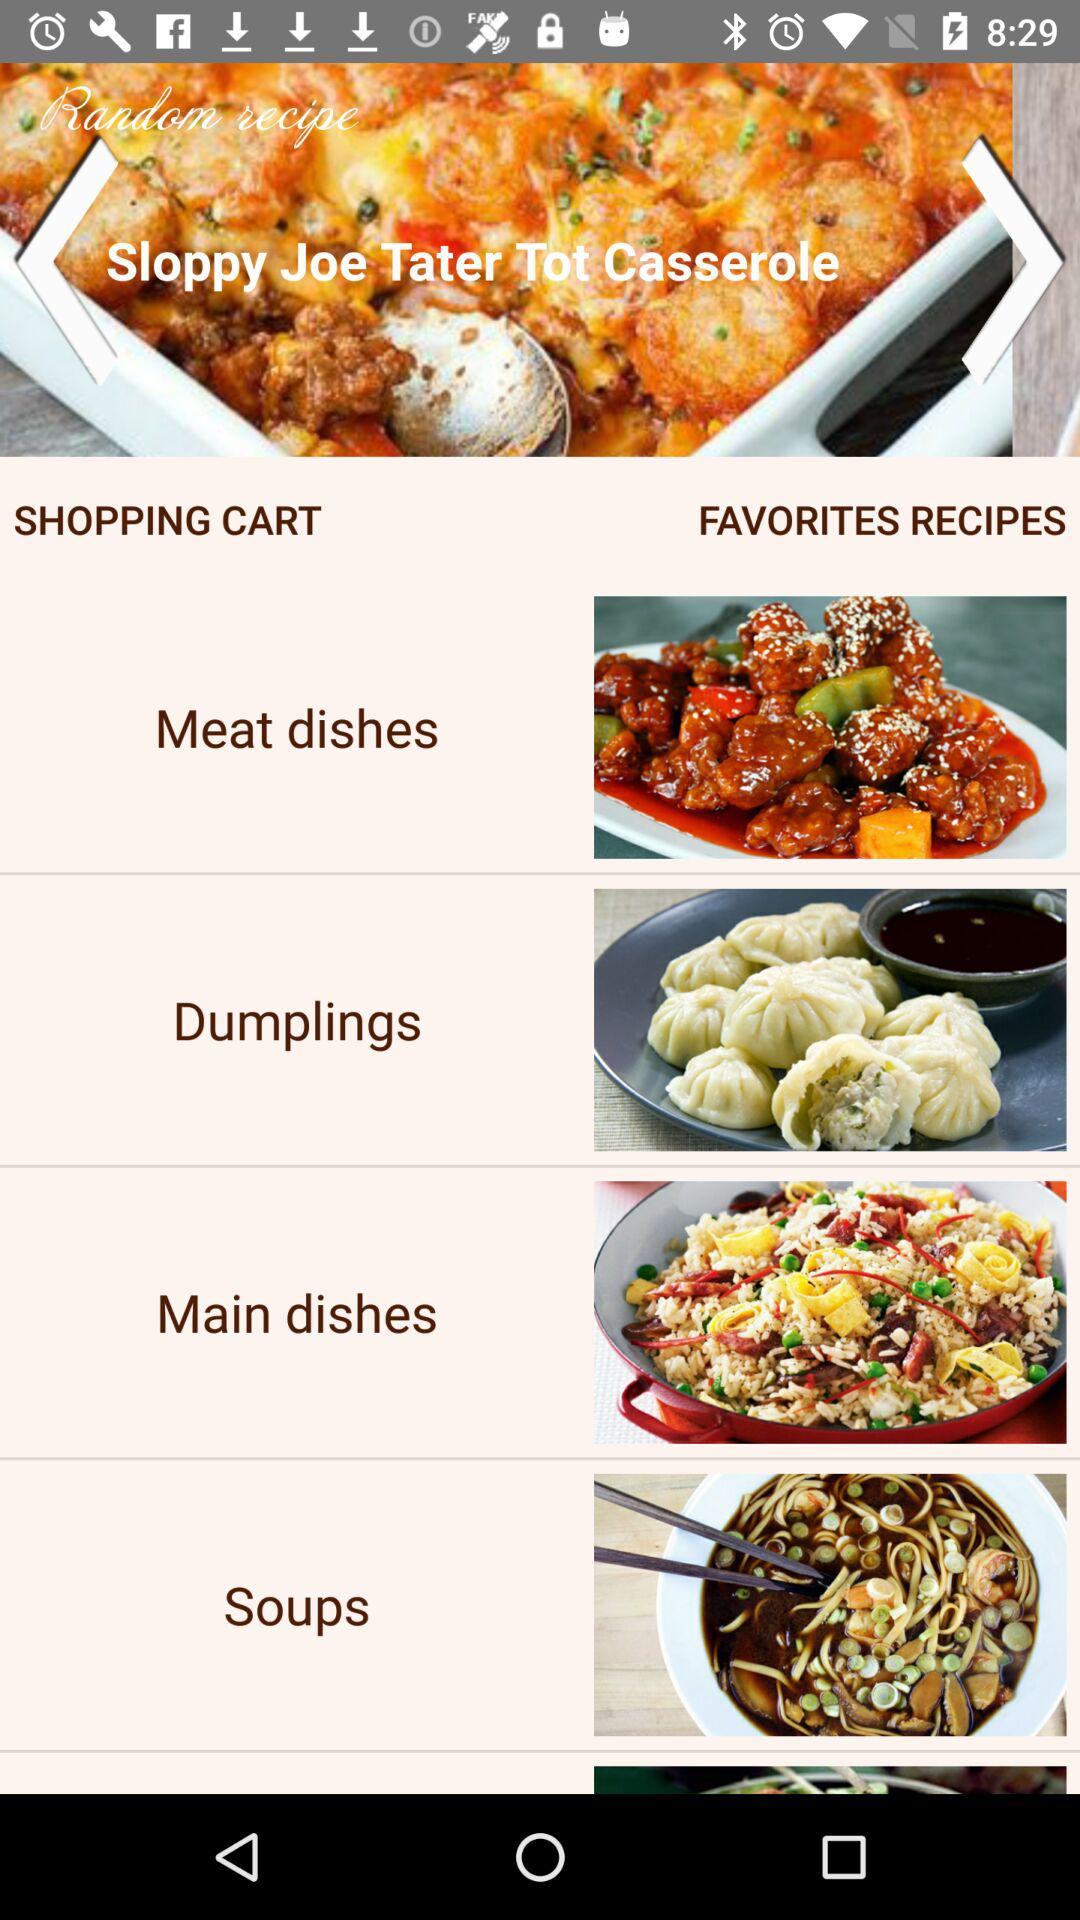How many dish name in this?
When the provided information is insufficient, respond with <no answer>. <no answer> 